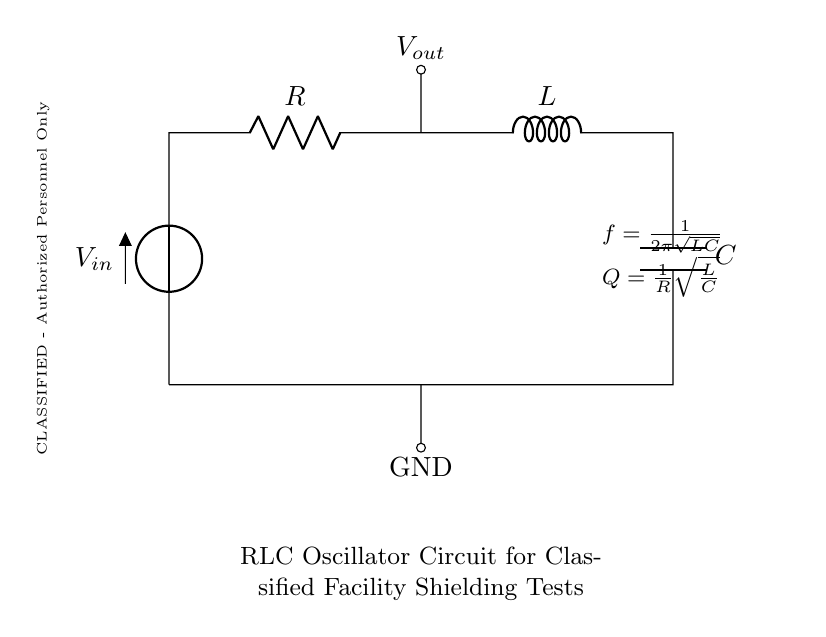What is the input voltage of the circuit? The input voltage is denoted as V_in, which is the voltage source connected to the circuit.
Answer: V_in What components are present in the circuit? The components in the circuit include a resistor (R), an inductor (L), and a capacitor (C), all connected in series.
Answer: Resistor, Inductor, Capacitor What is the output voltage node labeled as? The output voltage node is labeled V_out, indicating the voltage measured across the resistor.
Answer: V_out What is the formula for the resonant frequency? The formula for the resonant frequency is given as f = 1/(2π√(LC)), which describes the frequency at which the circuit oscillates.
Answer: f = 1/(2π√(LC)) How does the quality factor (Q) relate to resistance? The quality factor Q is calculated as Q = (1/R)√(L/C), indicating that it inversely depends on resistance and directly affects the circuit's performance.
Answer: Q = (1/R)√(L/C) Which components influence the oscillation frequency? The oscillation frequency is influenced by the values of the inductor (L) and capacitor (C) in the circuit, as shown in the resonant frequency formula.
Answer: Inductor (L) and Capacitor (C) What is the purpose of this RLC oscillator circuit? The purpose is to test the shielding effectiveness of classified research facilities by generating specific frequencies through oscillation.
Answer: Test shielding effectiveness 